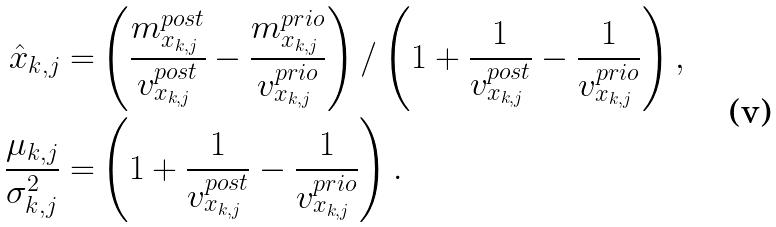Convert formula to latex. <formula><loc_0><loc_0><loc_500><loc_500>\hat { x } _ { k , j } = & \left ( \frac { m _ { x _ { k , j } } ^ { p o s t } } { v _ { x _ { k , j } } ^ { p o s t } } - \frac { m _ { x _ { k , j } } ^ { p r i o } } { v _ { x _ { k , j } } ^ { p r i o } } \right ) / \left ( 1 + \frac { 1 } { v _ { x _ { k , j } } ^ { p o s t } } - \frac { 1 } { v _ { x _ { k , j } } ^ { p r i o } } \right ) , \\ \frac { \mu _ { k , j } } { \sigma ^ { 2 } _ { k , j } } = & \left ( 1 + \frac { 1 } { v _ { x _ { k , j } } ^ { p o s t } } - \frac { 1 } { v _ { x _ { k , j } } ^ { p r i o } } \right ) .</formula> 